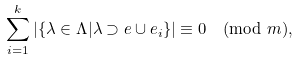Convert formula to latex. <formula><loc_0><loc_0><loc_500><loc_500>\sum _ { i = 1 } ^ { k } | \{ \lambda \in \Lambda | \lambda \supset e \cup e _ { i } \} | \equiv 0 \pmod { m } ,</formula> 